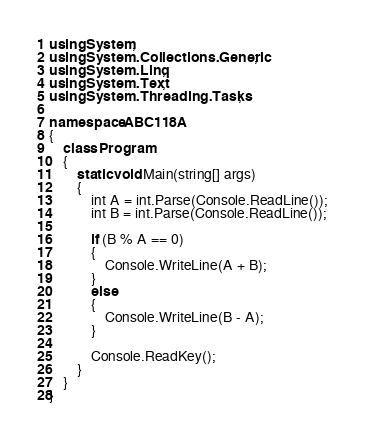Convert code to text. <code><loc_0><loc_0><loc_500><loc_500><_C#_>using System;
using System.Collections.Generic;
using System.Linq;
using System.Text;
using System.Threading.Tasks;

namespace ABC118A
{
    class Program
    {
        static void Main(string[] args)
        {
            int A = int.Parse(Console.ReadLine());
            int B = int.Parse(Console.ReadLine());

            if (B % A == 0)
            {
                Console.WriteLine(A + B);
            }
            else
            {
                Console.WriteLine(B - A);
            }

            Console.ReadKey();
        }
    }
}
</code> 